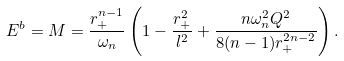<formula> <loc_0><loc_0><loc_500><loc_500>E ^ { b } = M = \frac { r _ { + } ^ { n - 1 } } { \omega _ { n } } \left ( 1 - \frac { r _ { + } ^ { 2 } } { l ^ { 2 } } + \frac { n \omega _ { n } ^ { 2 } Q ^ { 2 } } { 8 ( n - 1 ) r _ { + } ^ { 2 n - 2 } } \right ) .</formula> 